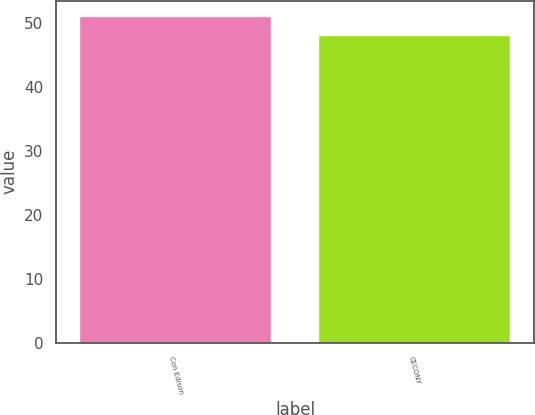Convert chart to OTSL. <chart><loc_0><loc_0><loc_500><loc_500><bar_chart><fcel>Con Edison<fcel>CECONY<nl><fcel>51<fcel>48<nl></chart> 